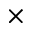Convert formula to latex. <formula><loc_0><loc_0><loc_500><loc_500>\times</formula> 